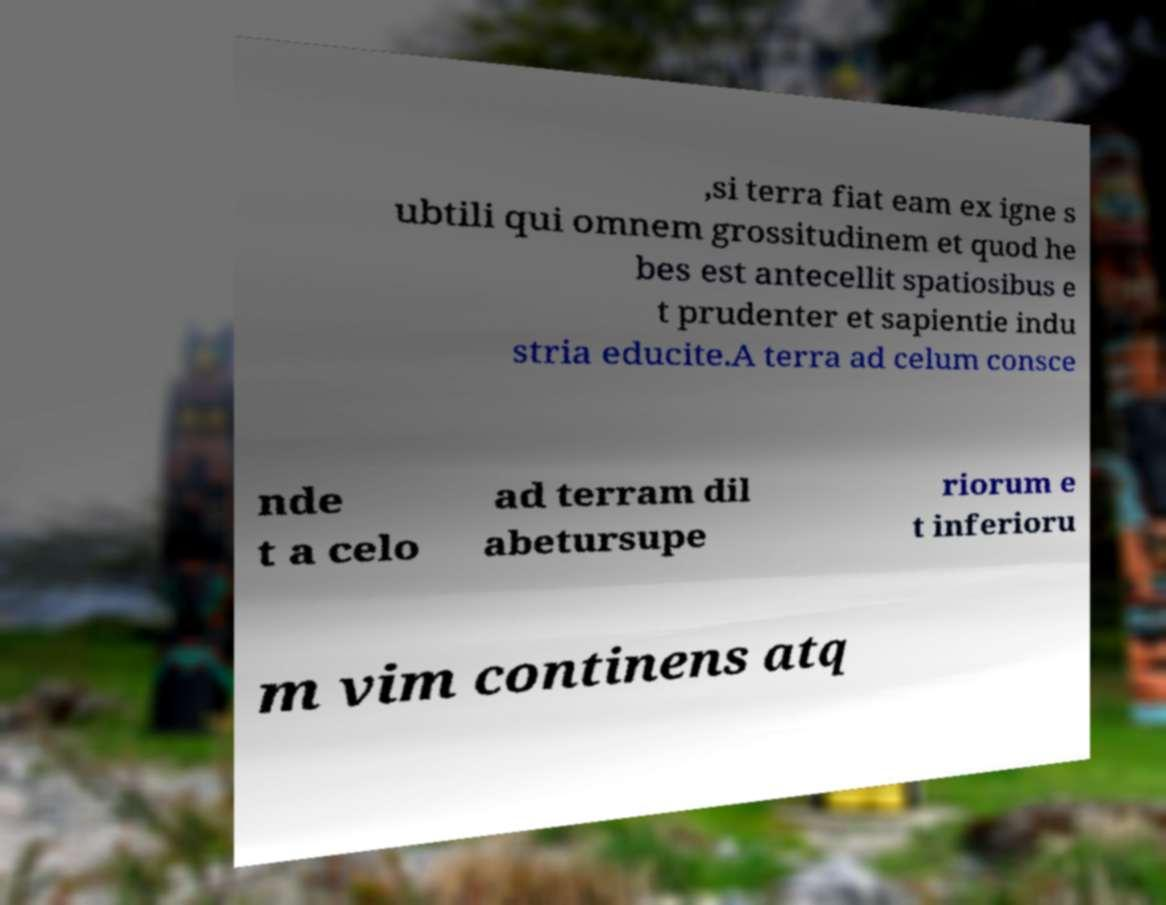Please identify and transcribe the text found in this image. ,si terra fiat eam ex igne s ubtili qui omnem grossitudinem et quod he bes est antecellit spatiosibus e t prudenter et sapientie indu stria educite.A terra ad celum consce nde t a celo ad terram dil abetursupe riorum e t inferioru m vim continens atq 